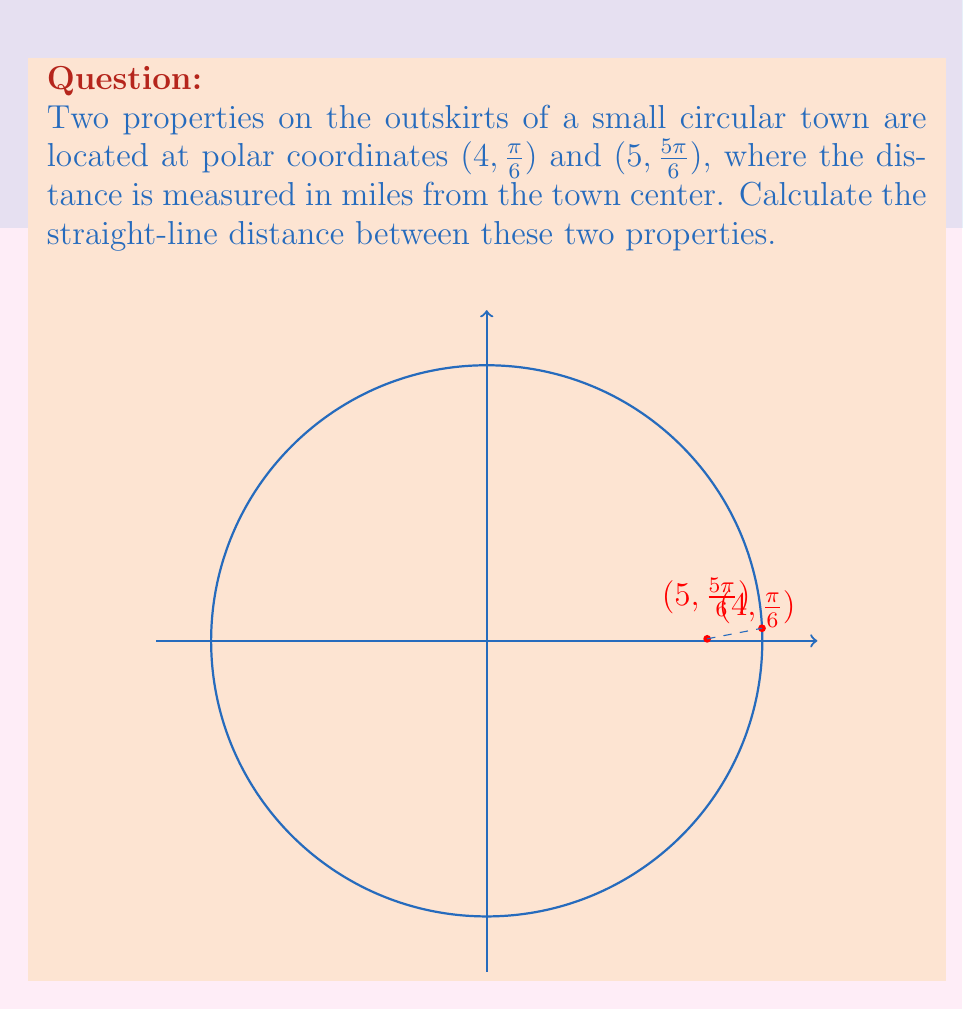Show me your answer to this math problem. To solve this problem, we'll use the formula for the distance between two points in polar coordinates:

$$d = \sqrt{r_1^2 + r_2^2 - 2r_1r_2\cos(\theta_2 - \theta_1)}$$

Where:
- $d$ is the distance between the two points
- $(r_1, \theta_1)$ are the polar coordinates of the first point
- $(r_2, \theta_2)$ are the polar coordinates of the second point

Let's plug in our values:
- $r_1 = 4$, $\theta_1 = \frac{\pi}{6}$
- $r_2 = 5$, $\theta_2 = \frac{5\pi}{6}$

First, calculate $\theta_2 - \theta_1$:
$$\frac{5\pi}{6} - \frac{\pi}{6} = \frac{4\pi}{6} = \frac{2\pi}{3}$$

Now, let's substitute these values into our formula:

$$\begin{align}
d &= \sqrt{4^2 + 5^2 - 2(4)(5)\cos(\frac{2\pi}{3})} \\
&= \sqrt{16 + 25 - 40\cos(\frac{2\pi}{3})} \\
&= \sqrt{41 - 40\cos(\frac{2\pi}{3})}
\end{align}$$

Recall that $\cos(\frac{2\pi}{3}) = -\frac{1}{2}$, so:

$$\begin{align}
d &= \sqrt{41 - 40(-\frac{1}{2})} \\
&= \sqrt{41 + 20} \\
&= \sqrt{61} \\
&\approx 7.81 \text{ miles}
\end{align}$$
Answer: The straight-line distance between the two properties is $\sqrt{61}$ miles, or approximately 7.81 miles. 